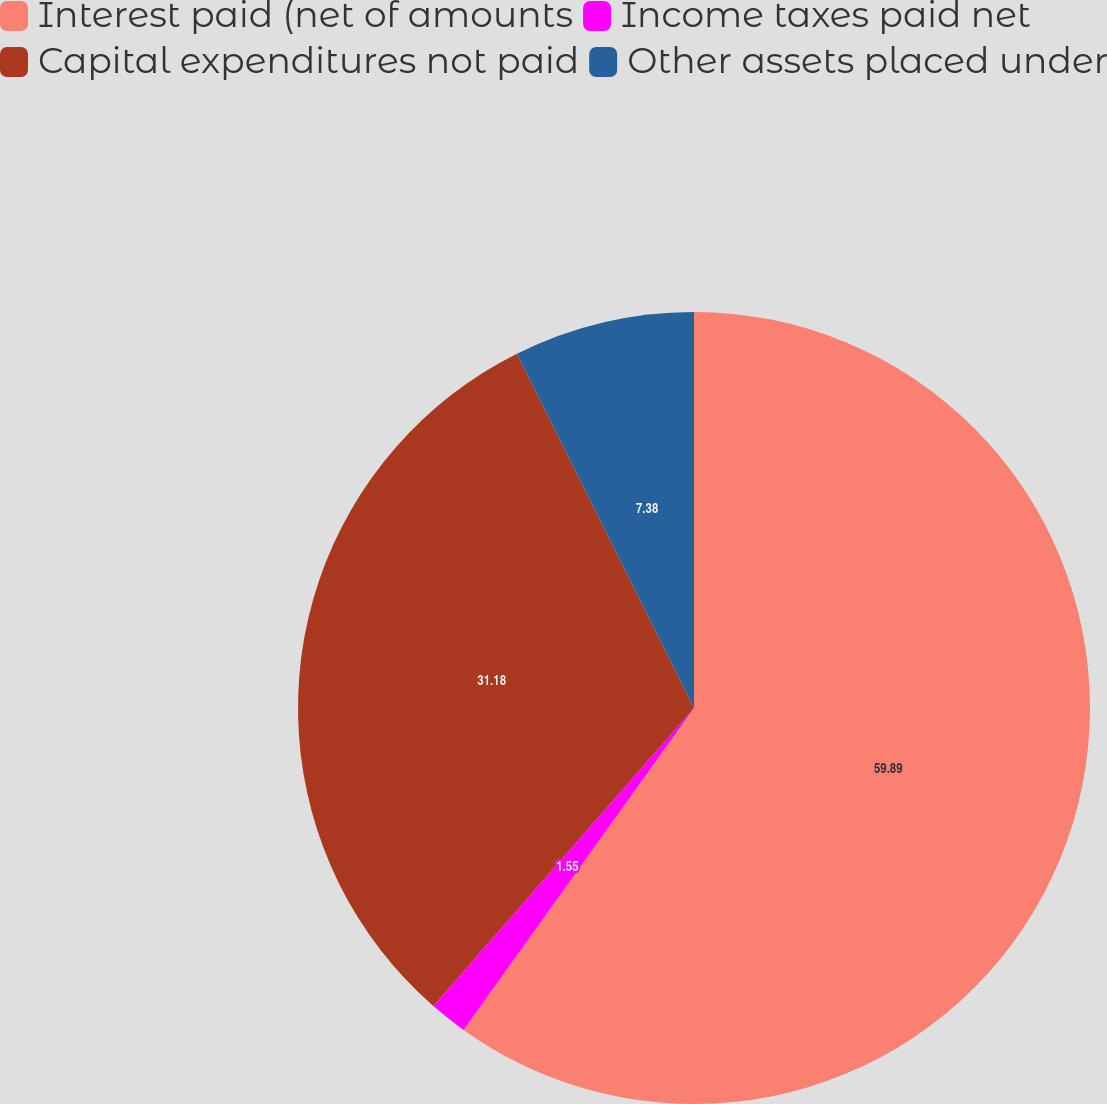<chart> <loc_0><loc_0><loc_500><loc_500><pie_chart><fcel>Interest paid (net of amounts<fcel>Income taxes paid net<fcel>Capital expenditures not paid<fcel>Other assets placed under<nl><fcel>59.88%<fcel>1.55%<fcel>31.18%<fcel>7.38%<nl></chart> 